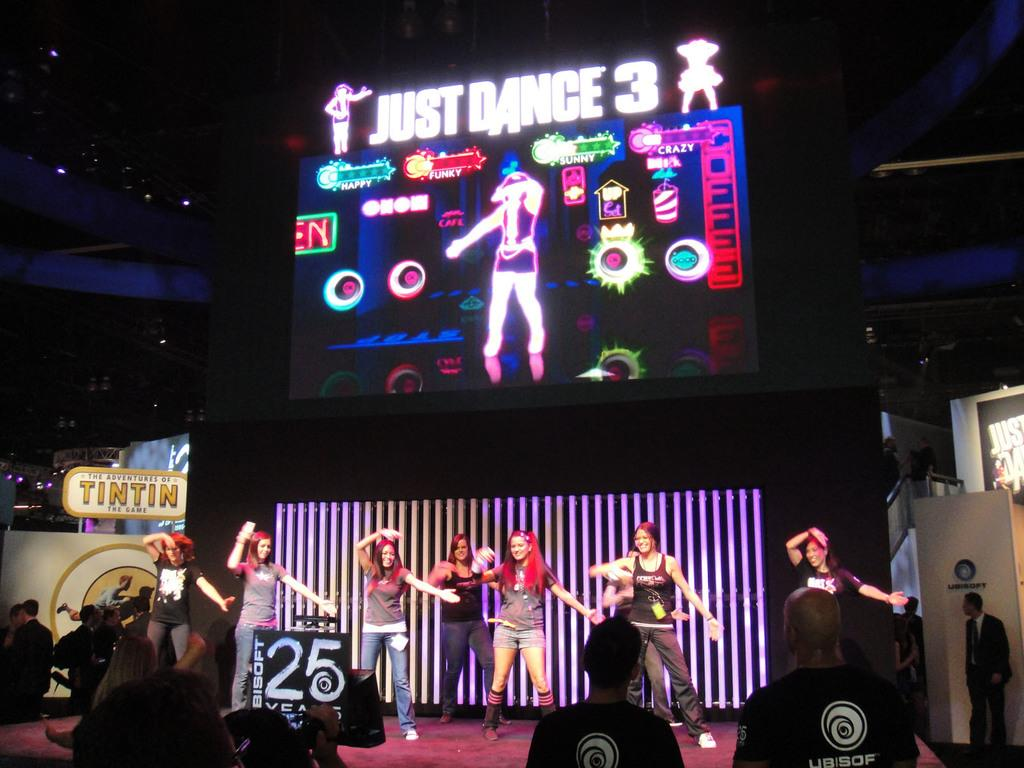What are the people in the image doing? There are people dancing in the image. Are there any other people in the image besides those dancing? Yes, there are people standing in the image. What decorations can be seen in the image? There are banners in the image. What type of illumination is present in the image? There are lights in the image. How would you describe the overall lighting in the image? The image is slightly dark. Can you see any trees in the image? There are no trees visible in the image. What type of drum is being played by the people in the image? There is no drum present in the image; the people are dancing and standing, but no musical instruments are mentioned in the provided facts. 